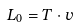Convert formula to latex. <formula><loc_0><loc_0><loc_500><loc_500>L _ { 0 } = T \cdot v</formula> 